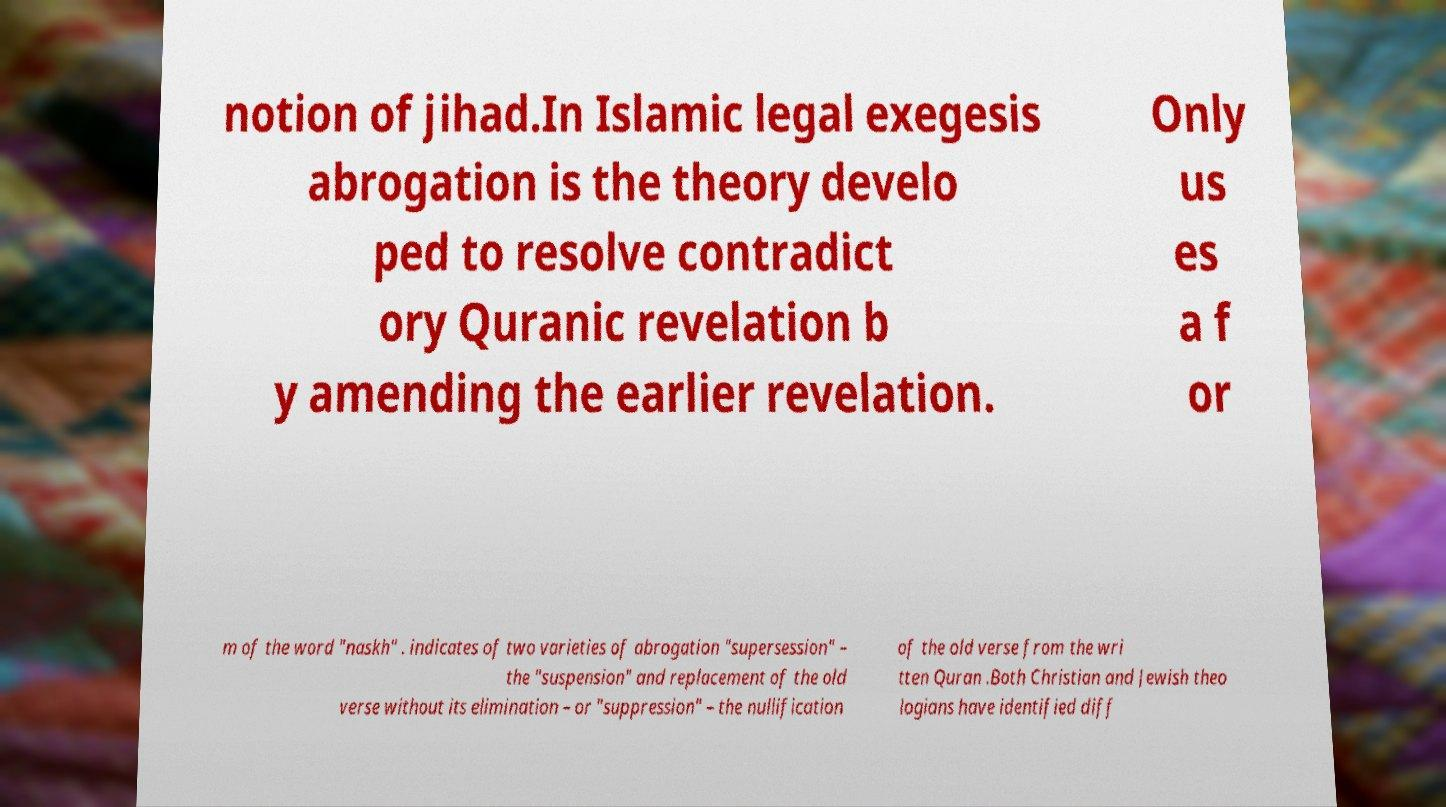For documentation purposes, I need the text within this image transcribed. Could you provide that? notion of jihad.In Islamic legal exegesis abrogation is the theory develo ped to resolve contradict ory Quranic revelation b y amending the earlier revelation. Only us es a f or m of the word "naskh" . indicates of two varieties of abrogation "supersession" – the "suspension" and replacement of the old verse without its elimination – or "suppression" – the nullification of the old verse from the wri tten Quran .Both Christian and Jewish theo logians have identified diff 